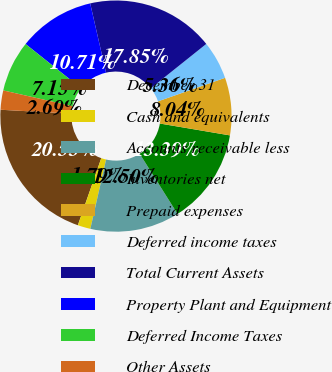Convert chart to OTSL. <chart><loc_0><loc_0><loc_500><loc_500><pie_chart><fcel>December 31<fcel>Cash and equivalents<fcel>Accounts receivable less<fcel>Inventories net<fcel>Prepaid expenses<fcel>Deferred income taxes<fcel>Total Current Assets<fcel>Property Plant and Equipment<fcel>Deferred Income Taxes<fcel>Other Assets<nl><fcel>20.53%<fcel>1.79%<fcel>12.5%<fcel>13.39%<fcel>8.04%<fcel>5.36%<fcel>17.85%<fcel>10.71%<fcel>7.15%<fcel>2.69%<nl></chart> 